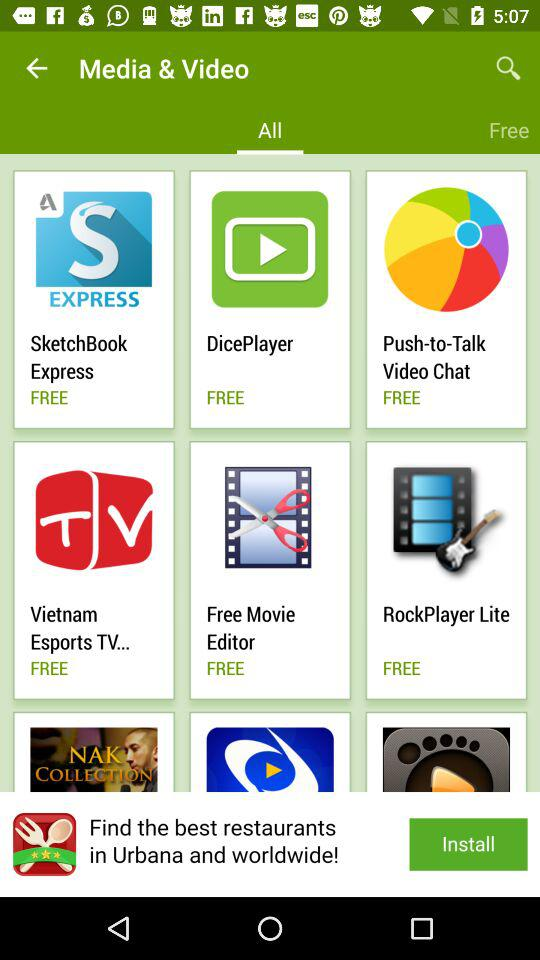Which tab am I on? You are on the "All" tab. 